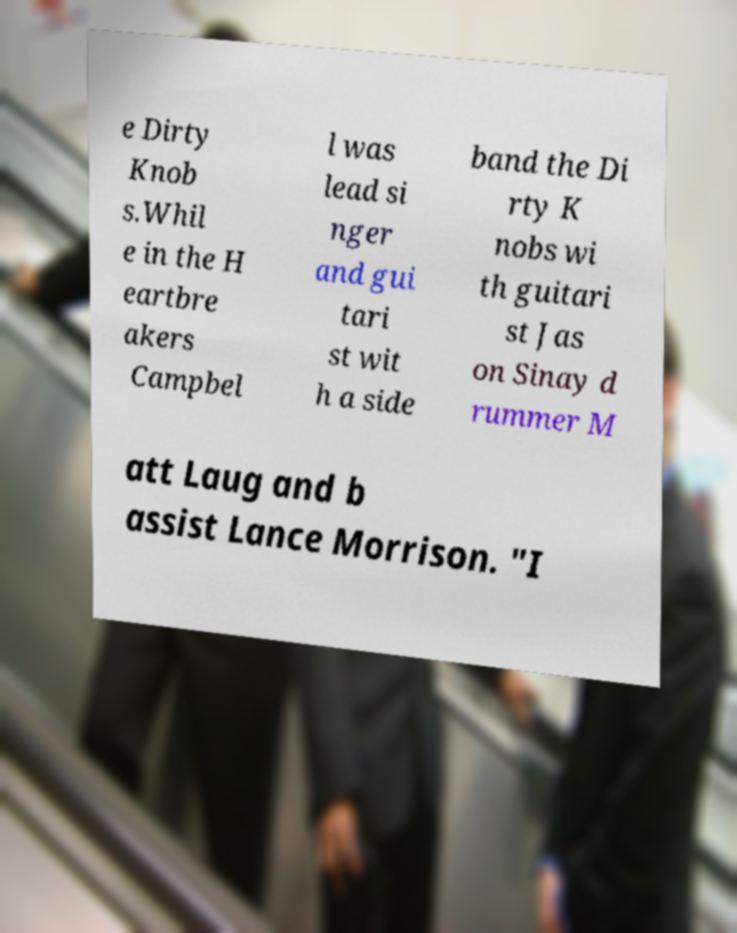There's text embedded in this image that I need extracted. Can you transcribe it verbatim? e Dirty Knob s.Whil e in the H eartbre akers Campbel l was lead si nger and gui tari st wit h a side band the Di rty K nobs wi th guitari st Jas on Sinay d rummer M att Laug and b assist Lance Morrison. "I 